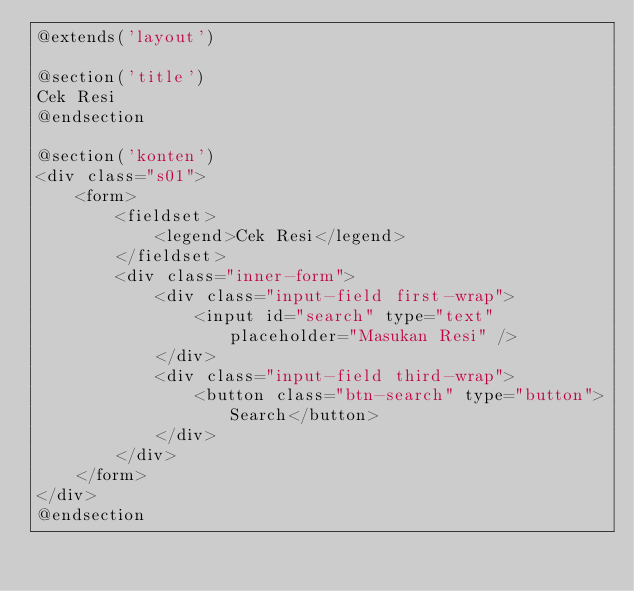<code> <loc_0><loc_0><loc_500><loc_500><_PHP_>@extends('layout')

@section('title')
Cek Resi
@endsection

@section('konten')
<div class="s01">
    <form>
        <fieldset>
            <legend>Cek Resi</legend>
        </fieldset>
        <div class="inner-form">
            <div class="input-field first-wrap">
                <input id="search" type="text" placeholder="Masukan Resi" />
            </div>
            <div class="input-field third-wrap">
                <button class="btn-search" type="button">Search</button>
            </div>
        </div>
    </form>
</div>
@endsection</code> 